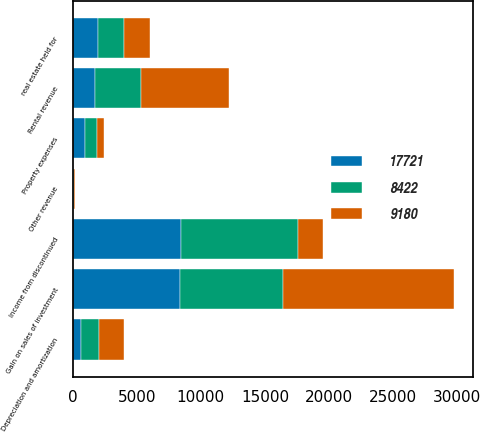Convert chart. <chart><loc_0><loc_0><loc_500><loc_500><stacked_bar_chart><ecel><fcel>real estate held for<fcel>Gain on sales of investment<fcel>Rental revenue<fcel>Other revenue<fcel>Depreciation and amortization<fcel>Property expenses<fcel>Income from discontinued<nl><fcel>17721<fcel>2010<fcel>8405<fcel>1771<fcel>32<fcel>636<fcel>937<fcel>8422<nl><fcel>8422<fcel>2009<fcel>8044<fcel>3592<fcel>45<fcel>1428<fcel>963<fcel>9180<nl><fcel>9180<fcel>2008<fcel>13314<fcel>6813<fcel>96<fcel>1929<fcel>573<fcel>1968.5<nl></chart> 